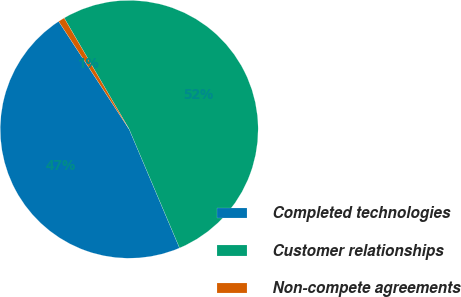Convert chart to OTSL. <chart><loc_0><loc_0><loc_500><loc_500><pie_chart><fcel>Completed technologies<fcel>Customer relationships<fcel>Non-compete agreements<nl><fcel>47.17%<fcel>52.03%<fcel>0.8%<nl></chart> 